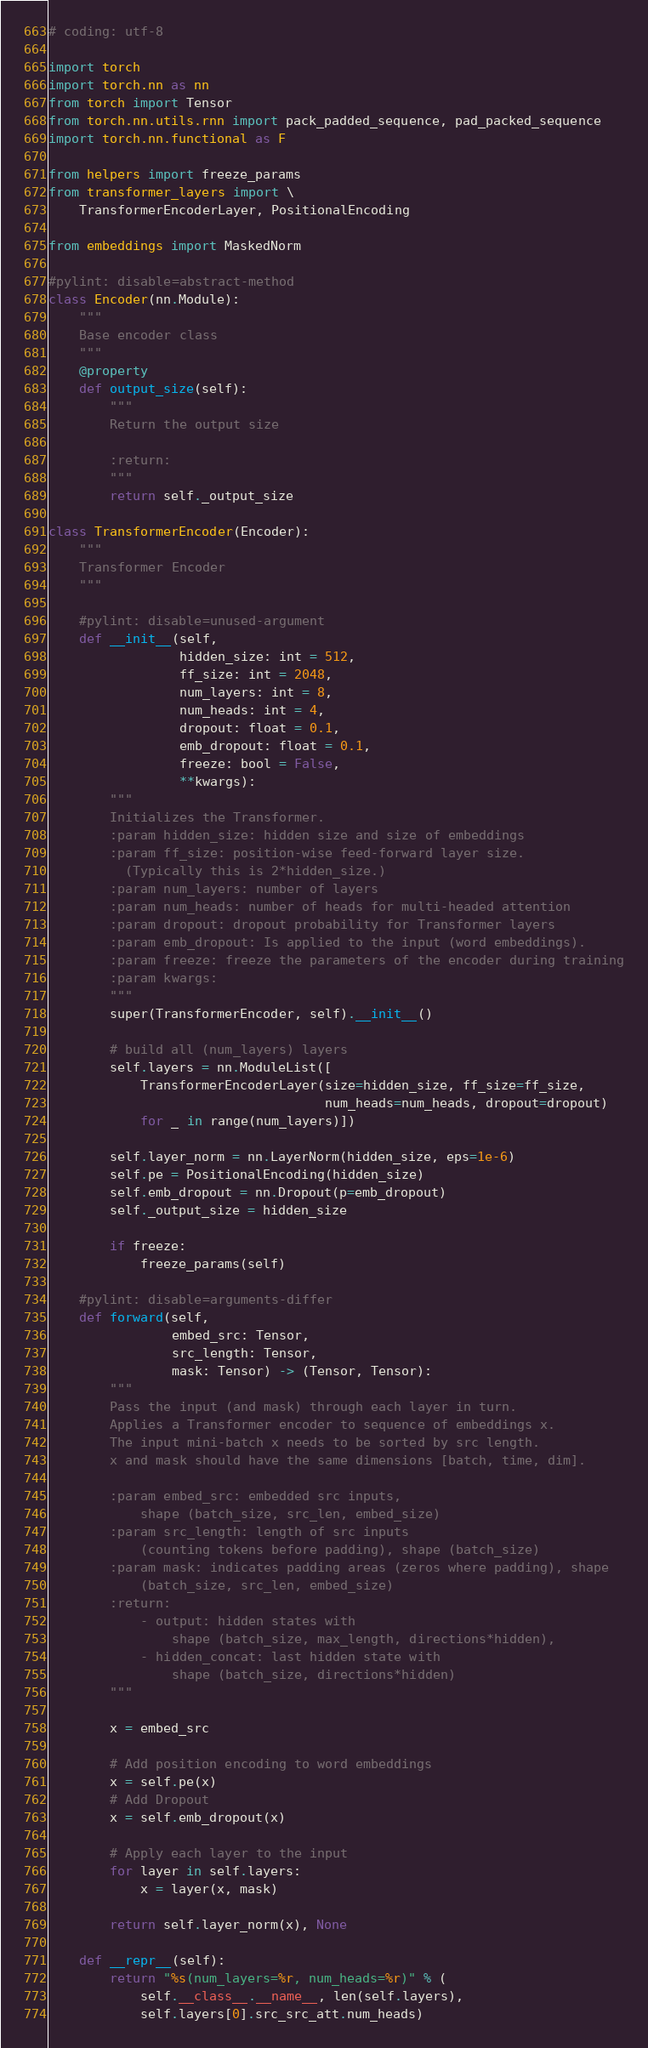Convert code to text. <code><loc_0><loc_0><loc_500><loc_500><_Python_># coding: utf-8

import torch
import torch.nn as nn
from torch import Tensor
from torch.nn.utils.rnn import pack_padded_sequence, pad_packed_sequence
import torch.nn.functional as F

from helpers import freeze_params
from transformer_layers import \
    TransformerEncoderLayer, PositionalEncoding

from embeddings import MaskedNorm

#pylint: disable=abstract-method
class Encoder(nn.Module):
    """
    Base encoder class
    """
    @property
    def output_size(self):
        """
        Return the output size

        :return:
        """
        return self._output_size

class TransformerEncoder(Encoder):
    """
    Transformer Encoder
    """

    #pylint: disable=unused-argument
    def __init__(self,
                 hidden_size: int = 512,
                 ff_size: int = 2048,
                 num_layers: int = 8,
                 num_heads: int = 4,
                 dropout: float = 0.1,
                 emb_dropout: float = 0.1,
                 freeze: bool = False,
                 **kwargs):
        """
        Initializes the Transformer.
        :param hidden_size: hidden size and size of embeddings
        :param ff_size: position-wise feed-forward layer size.
          (Typically this is 2*hidden_size.)
        :param num_layers: number of layers
        :param num_heads: number of heads for multi-headed attention
        :param dropout: dropout probability for Transformer layers
        :param emb_dropout: Is applied to the input (word embeddings).
        :param freeze: freeze the parameters of the encoder during training
        :param kwargs:
        """
        super(TransformerEncoder, self).__init__()

        # build all (num_layers) layers
        self.layers = nn.ModuleList([
            TransformerEncoderLayer(size=hidden_size, ff_size=ff_size,
                                    num_heads=num_heads, dropout=dropout)
            for _ in range(num_layers)])

        self.layer_norm = nn.LayerNorm(hidden_size, eps=1e-6)
        self.pe = PositionalEncoding(hidden_size)
        self.emb_dropout = nn.Dropout(p=emb_dropout)
        self._output_size = hidden_size

        if freeze:
            freeze_params(self)

    #pylint: disable=arguments-differ
    def forward(self,
                embed_src: Tensor,
                src_length: Tensor,
                mask: Tensor) -> (Tensor, Tensor):
        """
        Pass the input (and mask) through each layer in turn.
        Applies a Transformer encoder to sequence of embeddings x.
        The input mini-batch x needs to be sorted by src length.
        x and mask should have the same dimensions [batch, time, dim].

        :param embed_src: embedded src inputs,
            shape (batch_size, src_len, embed_size)
        :param src_length: length of src inputs
            (counting tokens before padding), shape (batch_size)
        :param mask: indicates padding areas (zeros where padding), shape
            (batch_size, src_len, embed_size)
        :return:
            - output: hidden states with
                shape (batch_size, max_length, directions*hidden),
            - hidden_concat: last hidden state with
                shape (batch_size, directions*hidden)
        """

        x = embed_src

        # Add position encoding to word embeddings
        x = self.pe(x)
        # Add Dropout
        x = self.emb_dropout(x)

        # Apply each layer to the input
        for layer in self.layers:
            x = layer(x, mask)

        return self.layer_norm(x), None

    def __repr__(self):
        return "%s(num_layers=%r, num_heads=%r)" % (
            self.__class__.__name__, len(self.layers),
            self.layers[0].src_src_att.num_heads)
</code> 